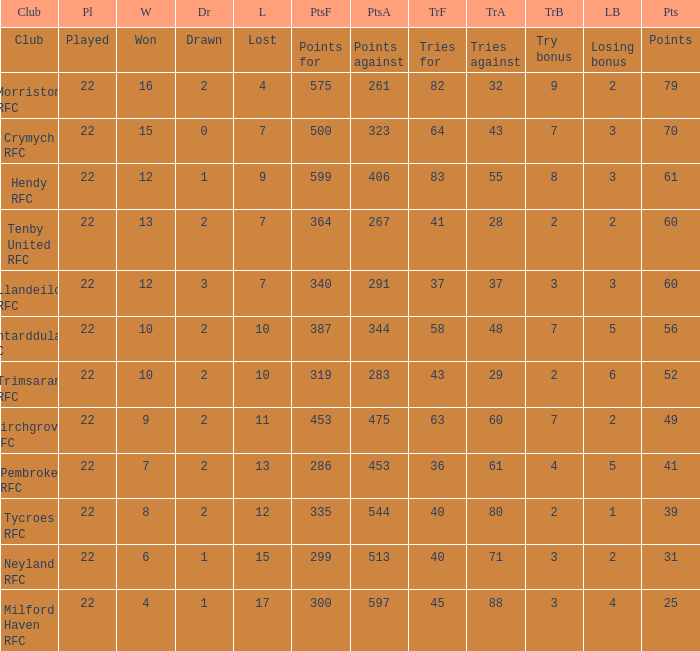What's the club with losing bonus being 1 Tycroes RFC. 